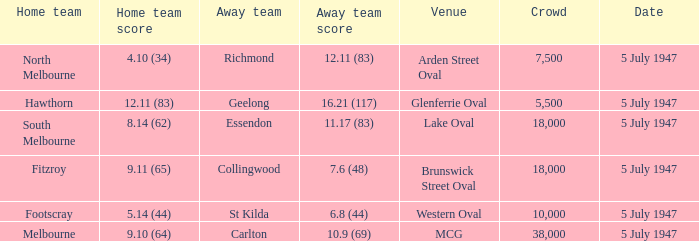What away team played against Footscray as the home team? St Kilda. 